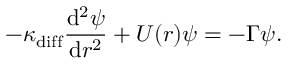<formula> <loc_0><loc_0><loc_500><loc_500>- \kappa _ { d i f f } \frac { d ^ { 2 } \psi } { d r ^ { 2 } } + U ( r ) \psi = - \Gamma \psi .</formula> 